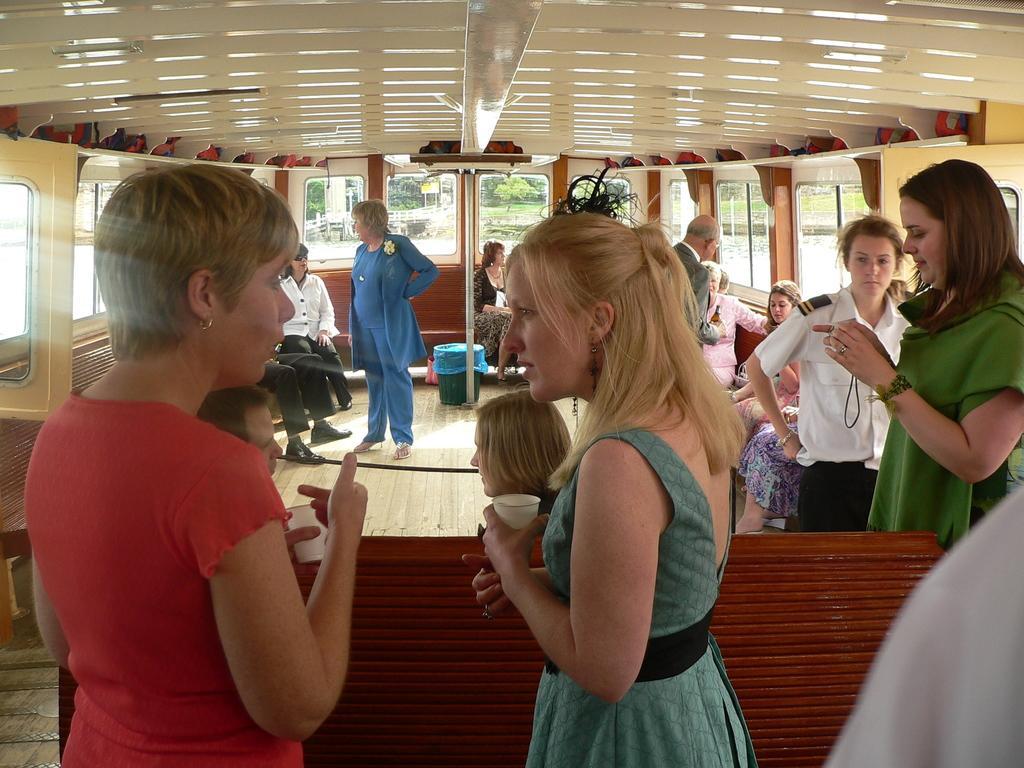What is the main subject of the image? The main subject of the image is a boat. Are there any people in the boat? Yes, there are people in the boat. What can be seen in the background of the image? Trees are visible in the image. What type of roof can be seen on the boat in the image? There is no roof present on the boat in the image. What color is the vest worn by the people in the boat? There is no information about the color of any vests worn by the people in the boat, as it is not mentioned in the provided facts. 